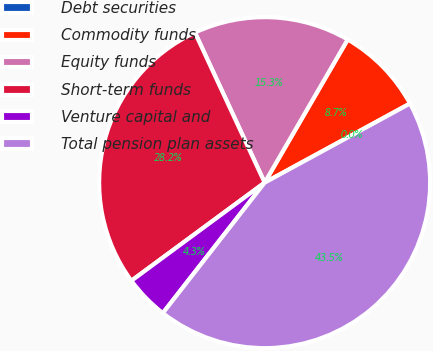<chart> <loc_0><loc_0><loc_500><loc_500><pie_chart><fcel>Debt securities<fcel>Commodity funds<fcel>Equity funds<fcel>Short-term funds<fcel>Venture capital and<fcel>Total pension plan assets<nl><fcel>0.0%<fcel>8.7%<fcel>15.29%<fcel>28.18%<fcel>4.35%<fcel>43.48%<nl></chart> 